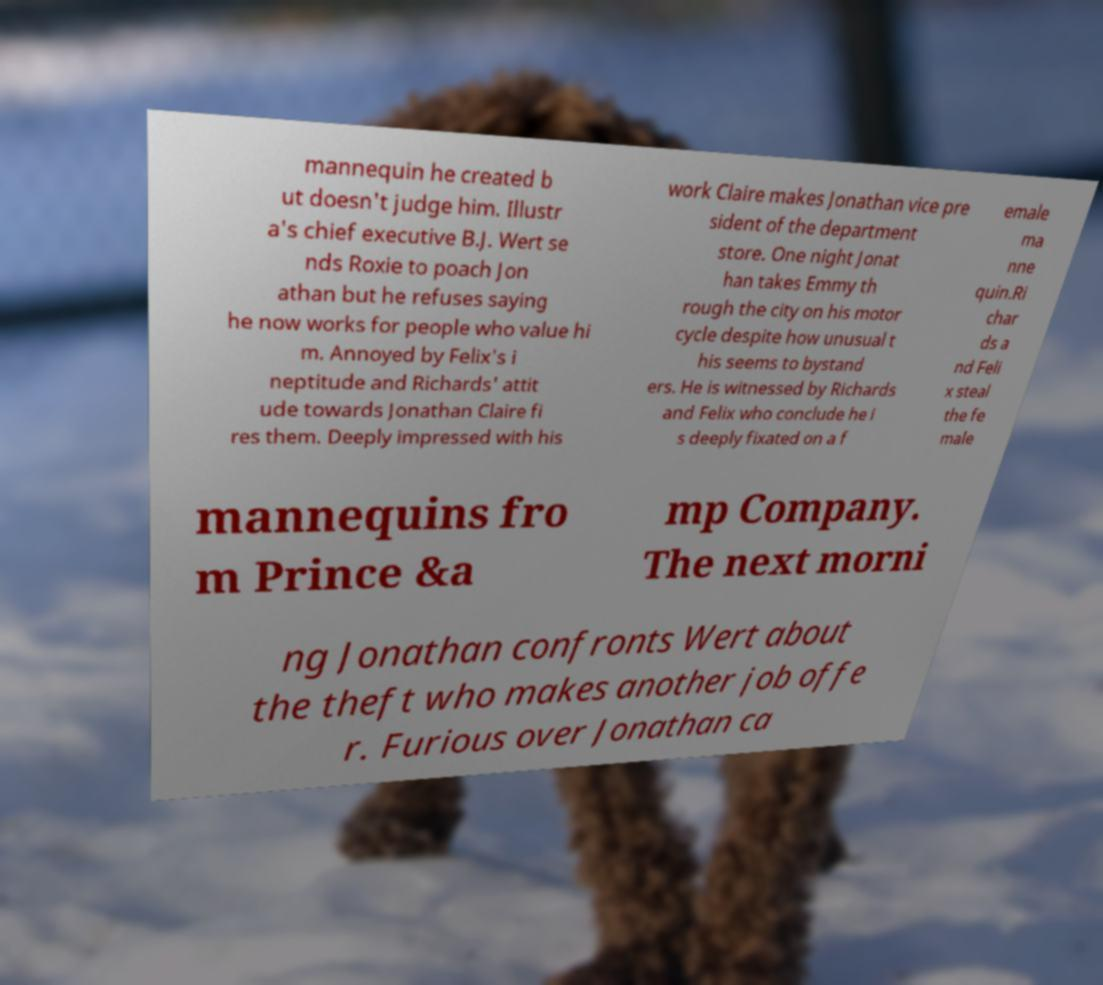For documentation purposes, I need the text within this image transcribed. Could you provide that? mannequin he created b ut doesn't judge him. Illustr a's chief executive B.J. Wert se nds Roxie to poach Jon athan but he refuses saying he now works for people who value hi m. Annoyed by Felix's i neptitude and Richards' attit ude towards Jonathan Claire fi res them. Deeply impressed with his work Claire makes Jonathan vice pre sident of the department store. One night Jonat han takes Emmy th rough the city on his motor cycle despite how unusual t his seems to bystand ers. He is witnessed by Richards and Felix who conclude he i s deeply fixated on a f emale ma nne quin.Ri char ds a nd Feli x steal the fe male mannequins fro m Prince &a mp Company. The next morni ng Jonathan confronts Wert about the theft who makes another job offe r. Furious over Jonathan ca 